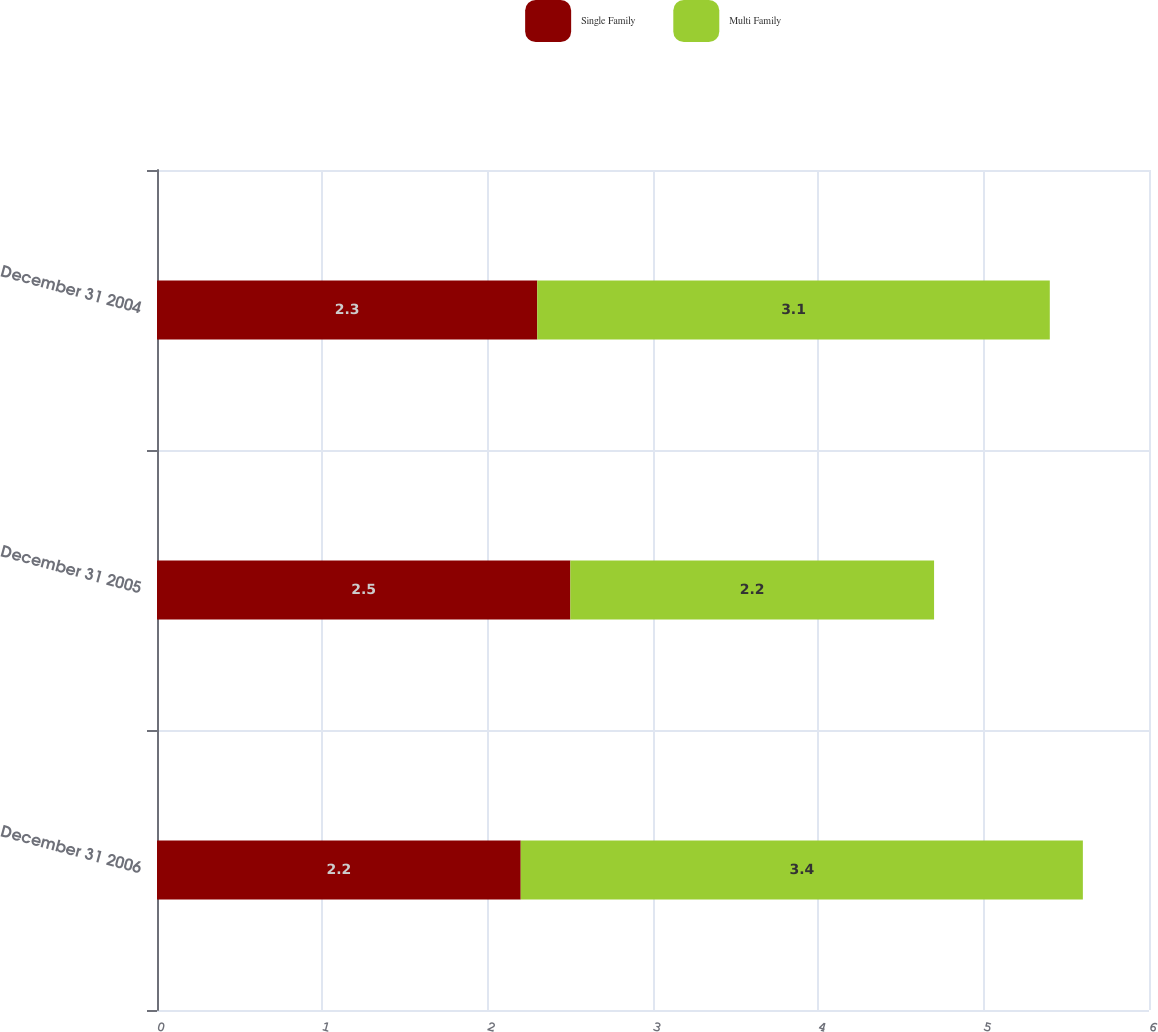<chart> <loc_0><loc_0><loc_500><loc_500><stacked_bar_chart><ecel><fcel>December 31 2006<fcel>December 31 2005<fcel>December 31 2004<nl><fcel>Single Family<fcel>2.2<fcel>2.5<fcel>2.3<nl><fcel>Multi Family<fcel>3.4<fcel>2.2<fcel>3.1<nl></chart> 